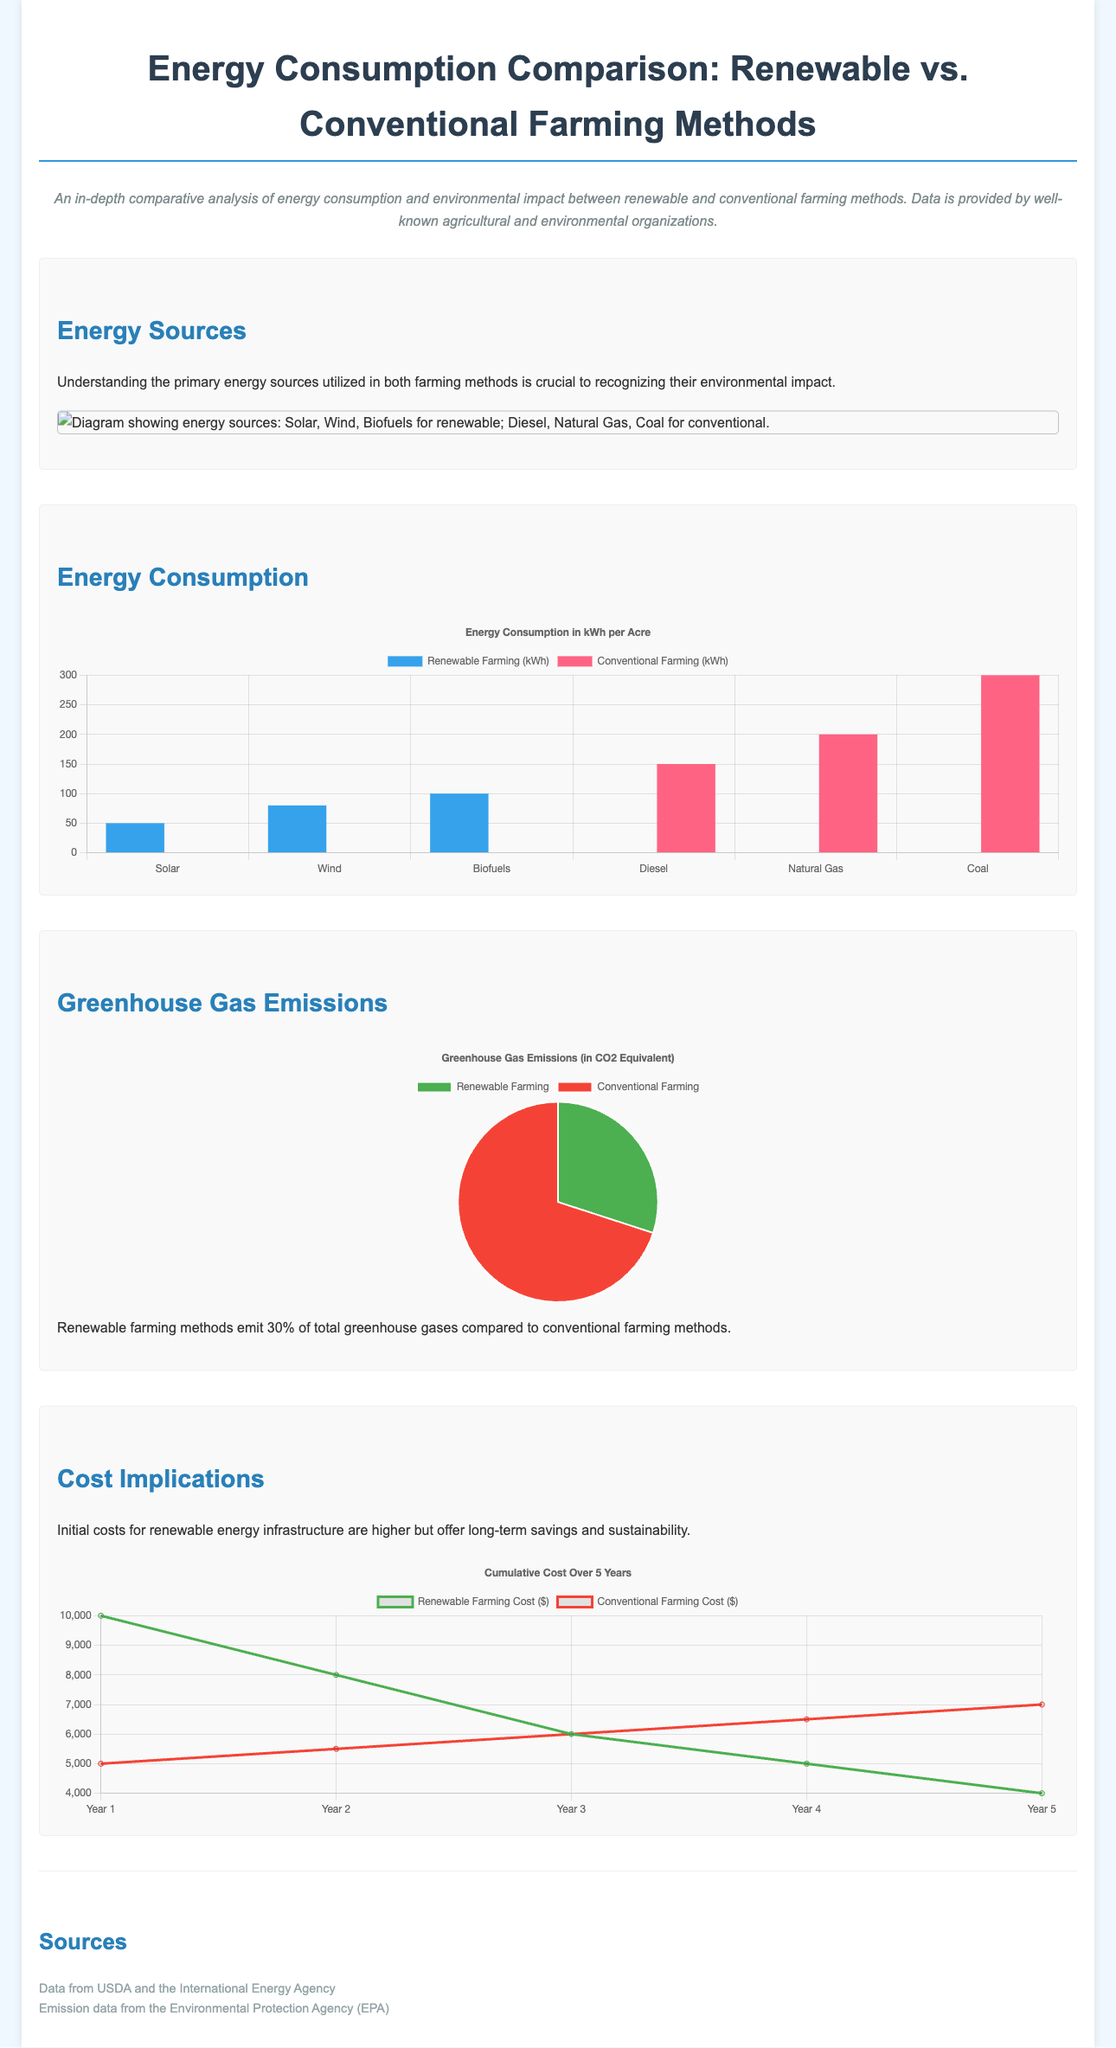What are the three renewable energy sources mentioned? The infographic lists solar, wind, and biofuels as the three renewable energy sources utilized in farming methods.
Answer: Solar, Wind, Biofuels What is the total energy consumption for conventional farming using coal? The chart shows that coal has an energy consumption of 300 kWh per acre for conventional farming methods.
Answer: 300 kWh What percentage of greenhouse gas emissions come from renewable farming methods? The document states that renewable farming methods emit 30% of total greenhouse gases compared to conventional methods.
Answer: 30% Which farming method has higher initial costs? The section on cost implications indicates that renewable energy infrastructure has higher initial costs compared to conventional methods.
Answer: Renewable What is the trend in cumulative cost over five years for renewable farming? The cost chart suggests that renewable farming costs decrease over the five-year period.
Answer: Decrease What is the total energy consumption for renewable farming using biofuels? According to the energy consumption chart, biofuels have an energy consumption of 100 kWh per acre for renewable farming methods.
Answer: 100 kWh Which institution provided the emission data? The sources cited in the document mention the Environmental Protection Agency (EPA) as the provider of emission data.
Answer: Environmental Protection Agency How does the cumulative cost of conventional farming change by year 5? The cost chart indicates that the cumulative cost for conventional farming increases by year 5.
Answer: Increase 